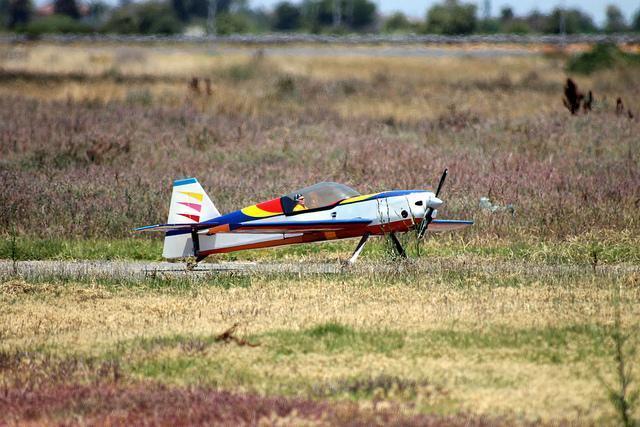How many horses are there?
Give a very brief answer. 0. 